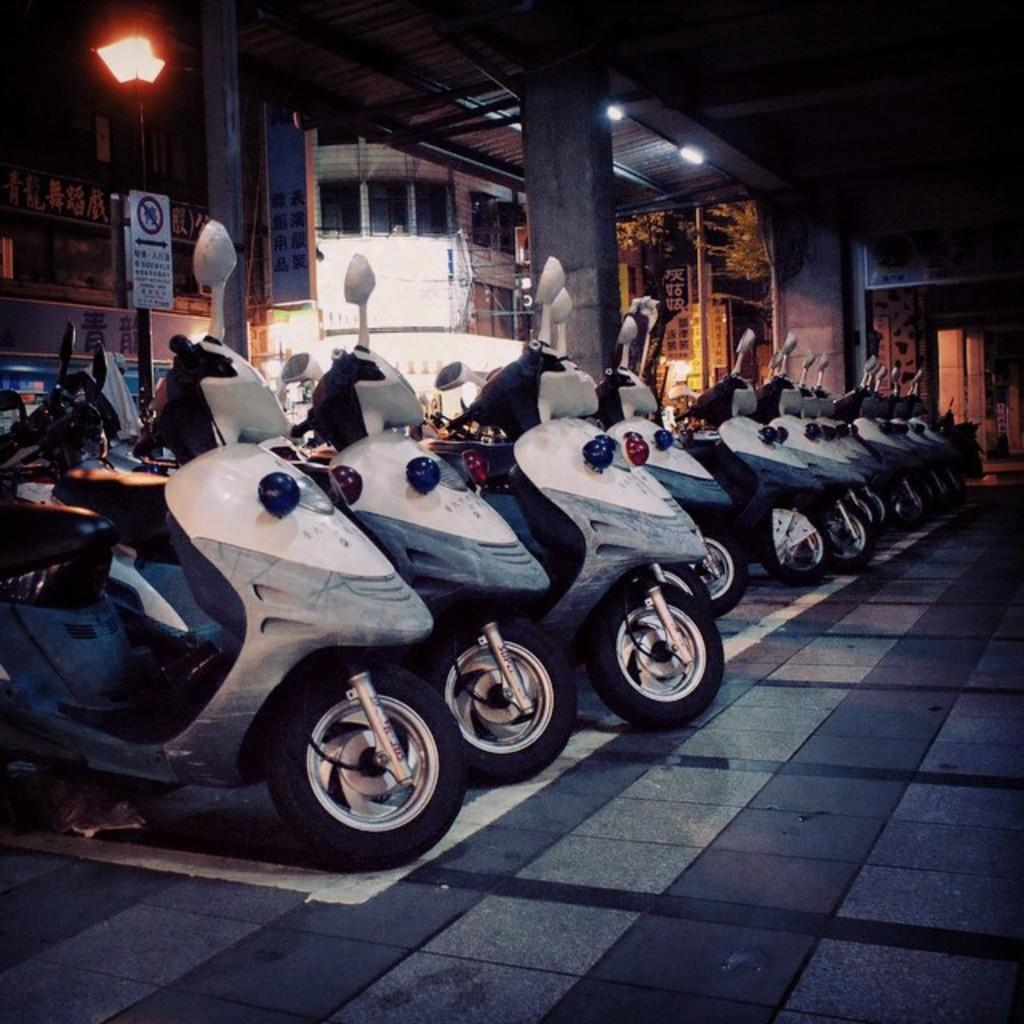What type of event is taking place in the image? The facts provided do not give enough information to determine the type of event taking place in the image. What type of vehicles are in the image? There are motorcycles in the image. What structures can be seen in the image? There are buildings in the image. What additional object is present in the image? There is a banner in the image. What type of illumination is present in the image? There are lights in the image. What type of flooring can be seen in the image? There are white and blue color tiles in the image. What is the sound of thunder like in the image? There is no mention of thunder or any sound in the image, so it cannot be determined. 